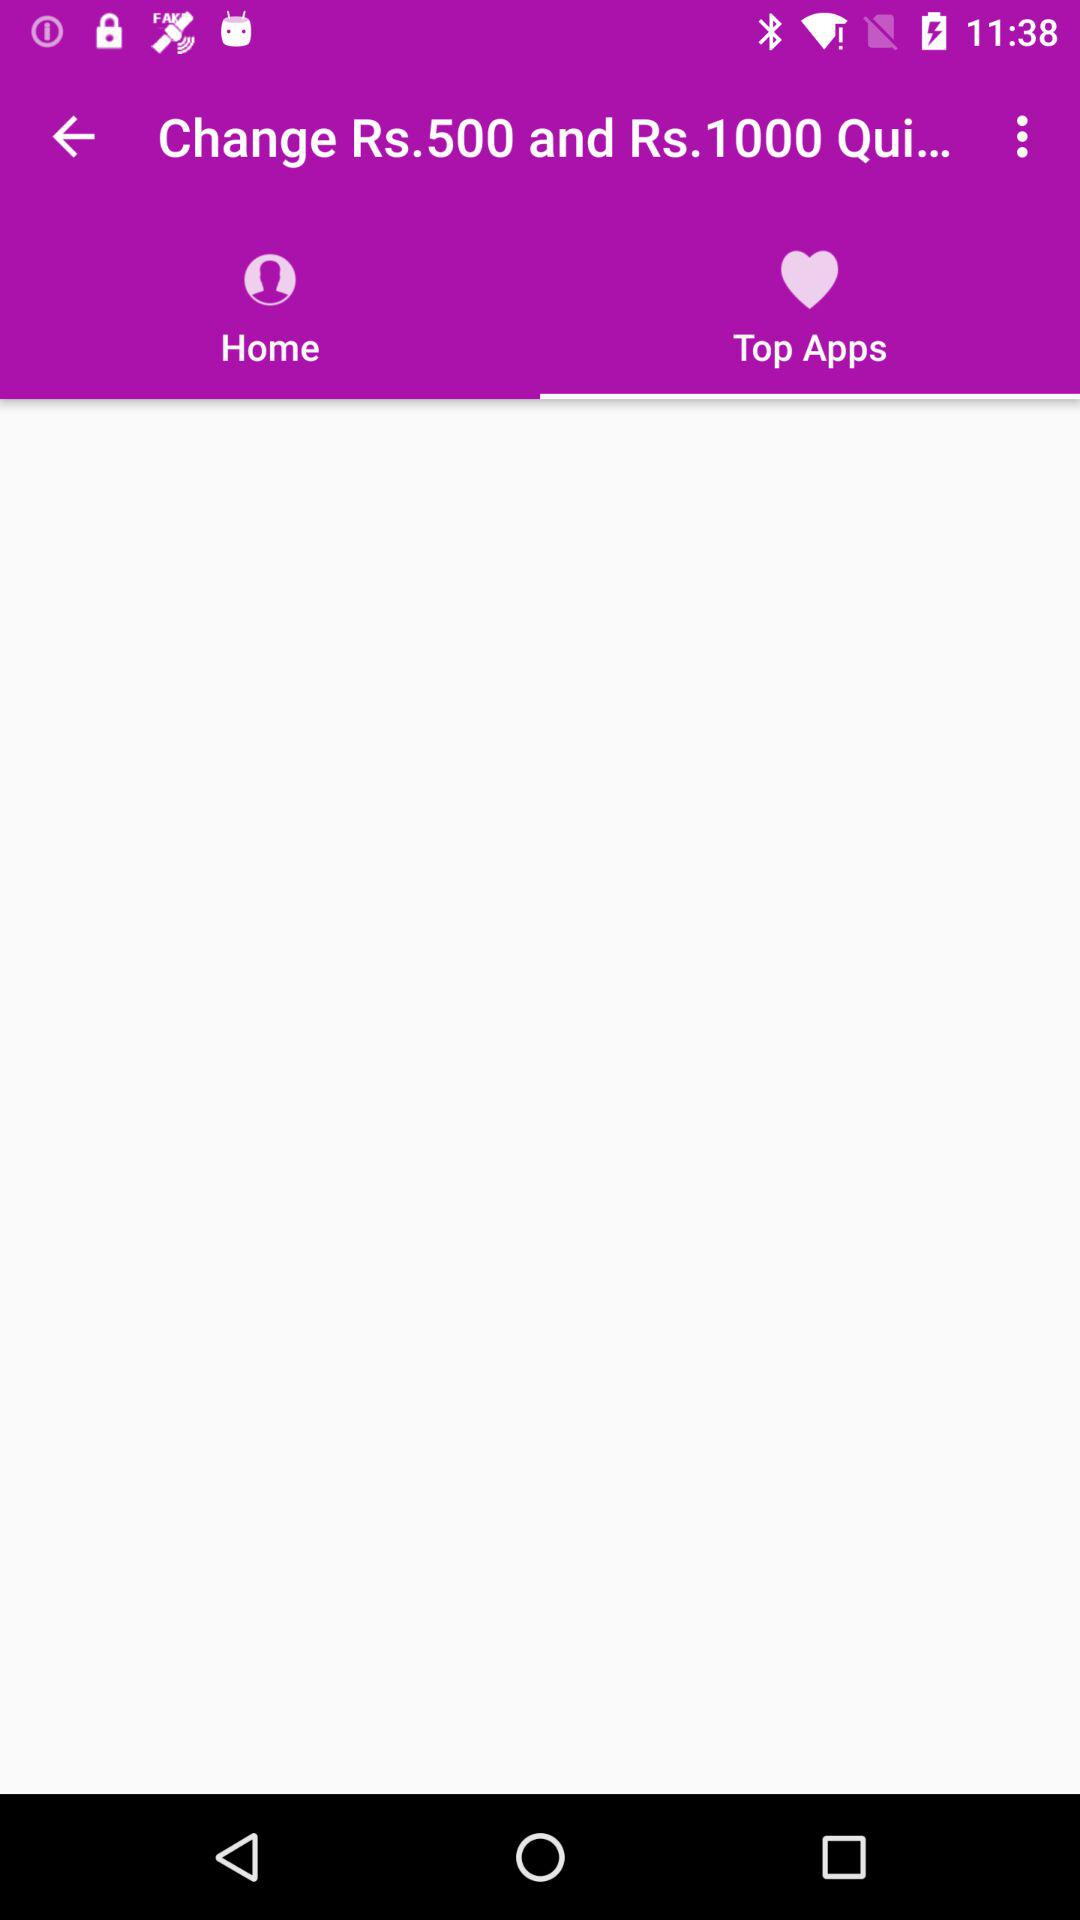On which tab am I now? I am now on the tab "Top Apps". 